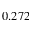Convert formula to latex. <formula><loc_0><loc_0><loc_500><loc_500>0 . 2 7 2</formula> 